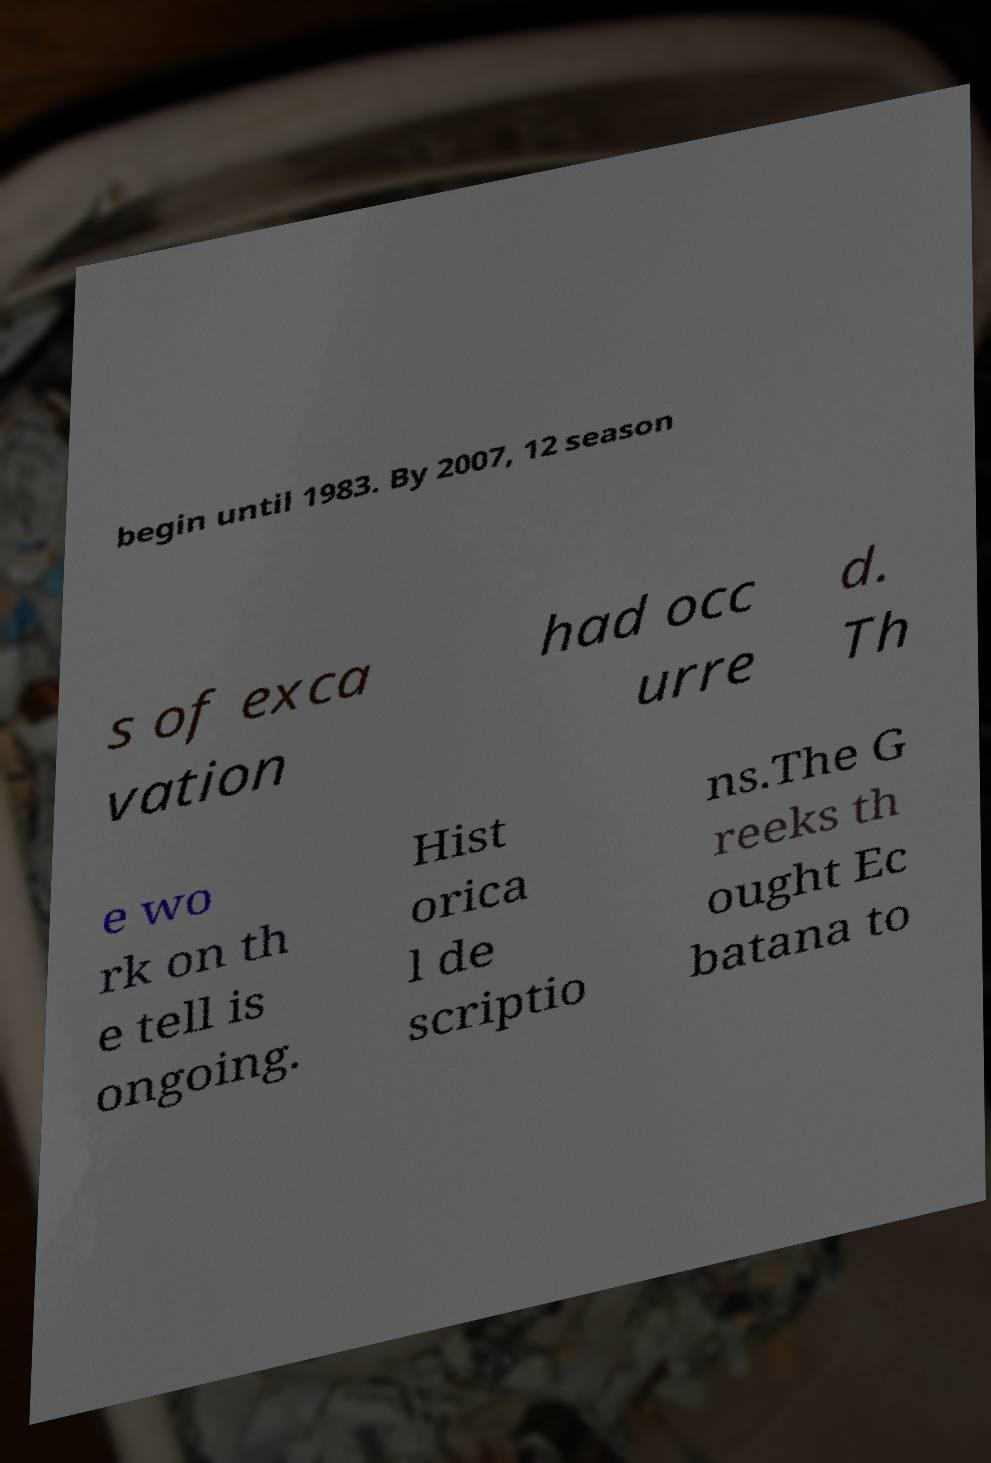Please read and relay the text visible in this image. What does it say? begin until 1983. By 2007, 12 season s of exca vation had occ urre d. Th e wo rk on th e tell is ongoing. Hist orica l de scriptio ns.The G reeks th ought Ec batana to 